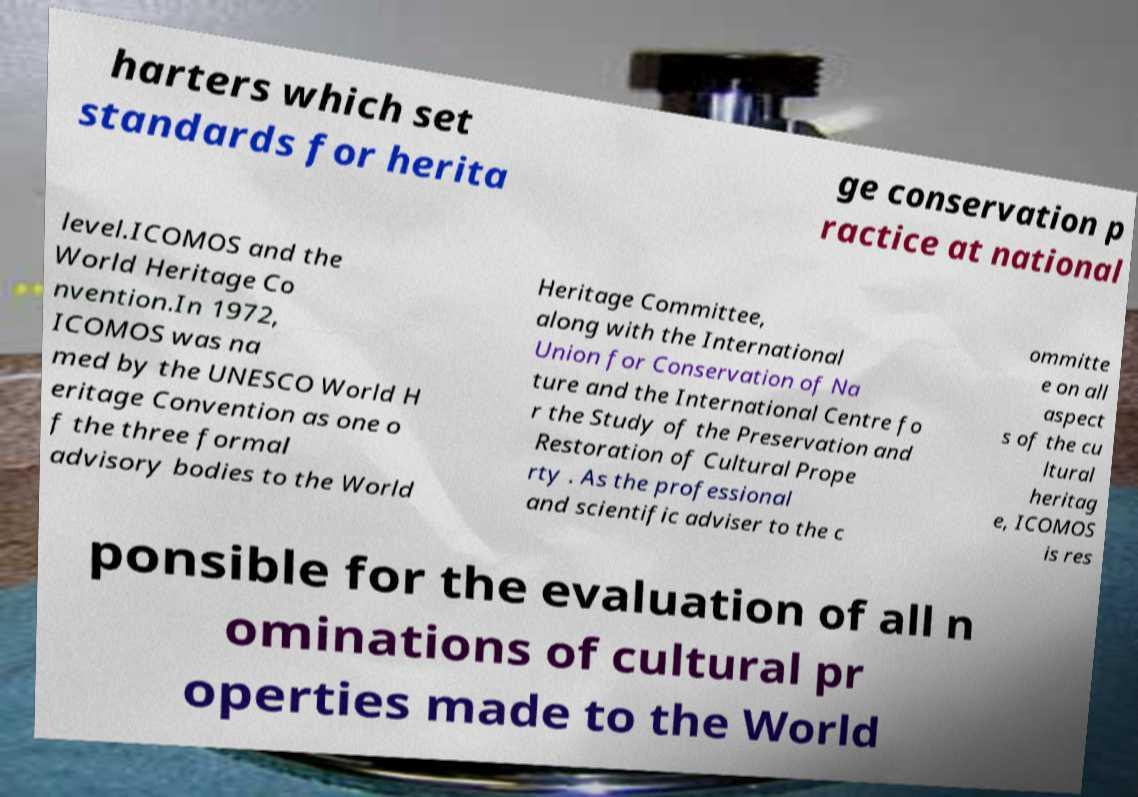Please identify and transcribe the text found in this image. harters which set standards for herita ge conservation p ractice at national level.ICOMOS and the World Heritage Co nvention.In 1972, ICOMOS was na med by the UNESCO World H eritage Convention as one o f the three formal advisory bodies to the World Heritage Committee, along with the International Union for Conservation of Na ture and the International Centre fo r the Study of the Preservation and Restoration of Cultural Prope rty . As the professional and scientific adviser to the c ommitte e on all aspect s of the cu ltural heritag e, ICOMOS is res ponsible for the evaluation of all n ominations of cultural pr operties made to the World 